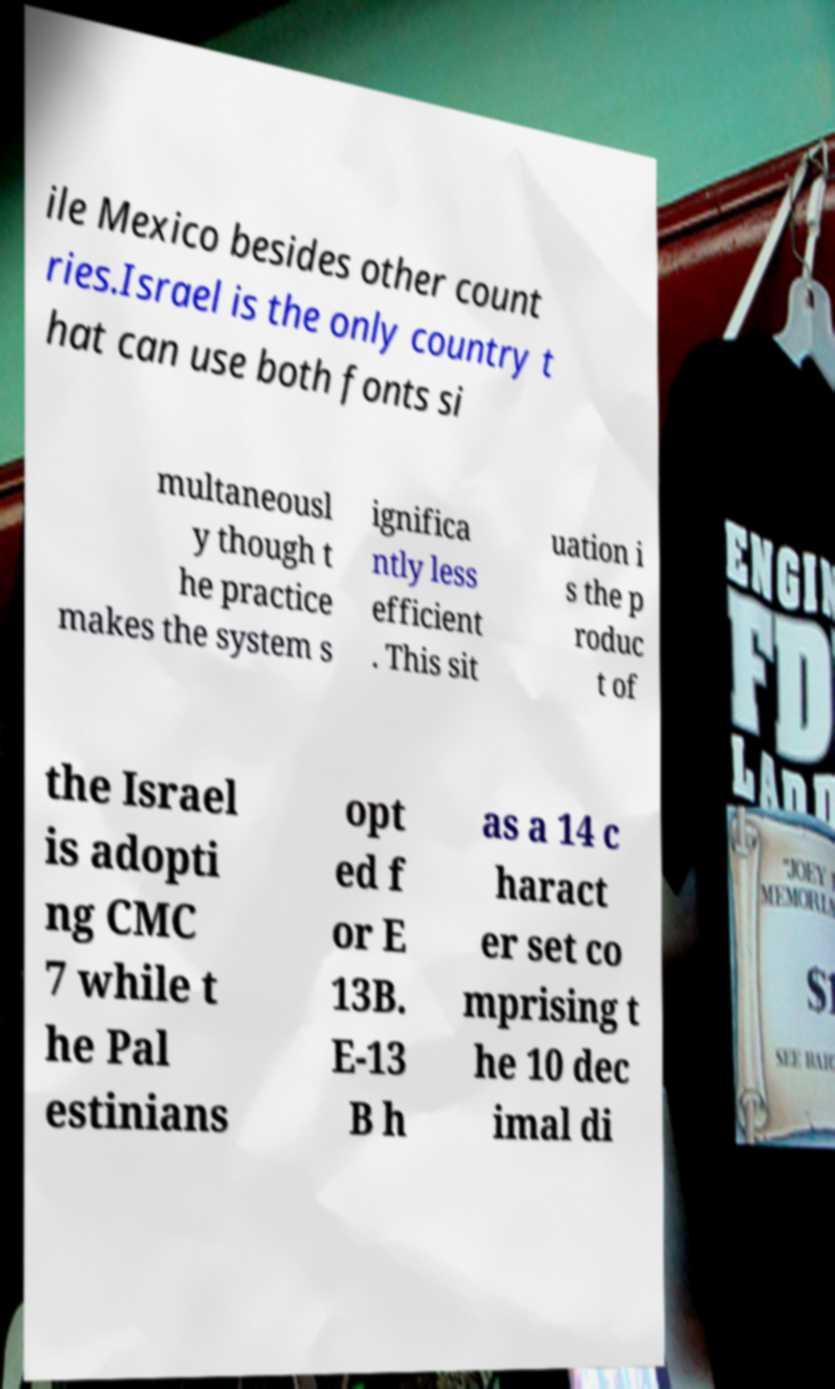For documentation purposes, I need the text within this image transcribed. Could you provide that? ile Mexico besides other count ries.Israel is the only country t hat can use both fonts si multaneousl y though t he practice makes the system s ignifica ntly less efficient . This sit uation i s the p roduc t of the Israel is adopti ng CMC 7 while t he Pal estinians opt ed f or E 13B. E-13 B h as a 14 c haract er set co mprising t he 10 dec imal di 